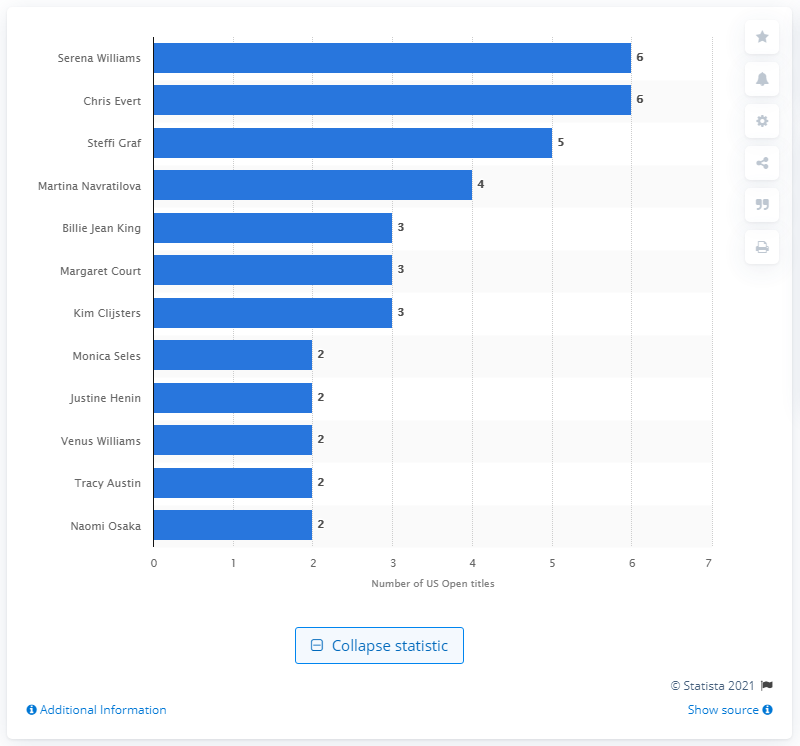List a handful of essential elements in this visual. The U.S. Open was won five times between 1988 and 1996 by Steffi Graf, who is a former world no. 1 professional tennis player from Germany. 